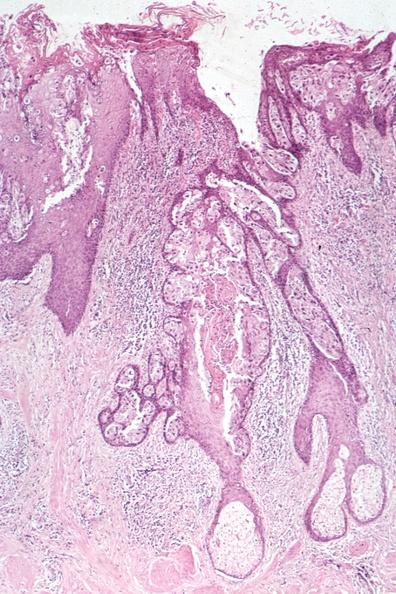what is present?
Answer the question using a single word or phrase. Breast 